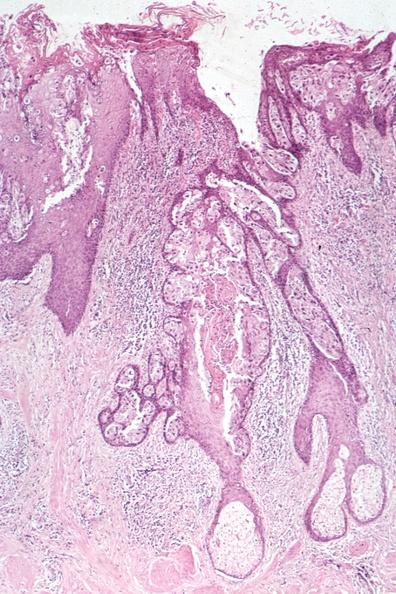what is present?
Answer the question using a single word or phrase. Breast 